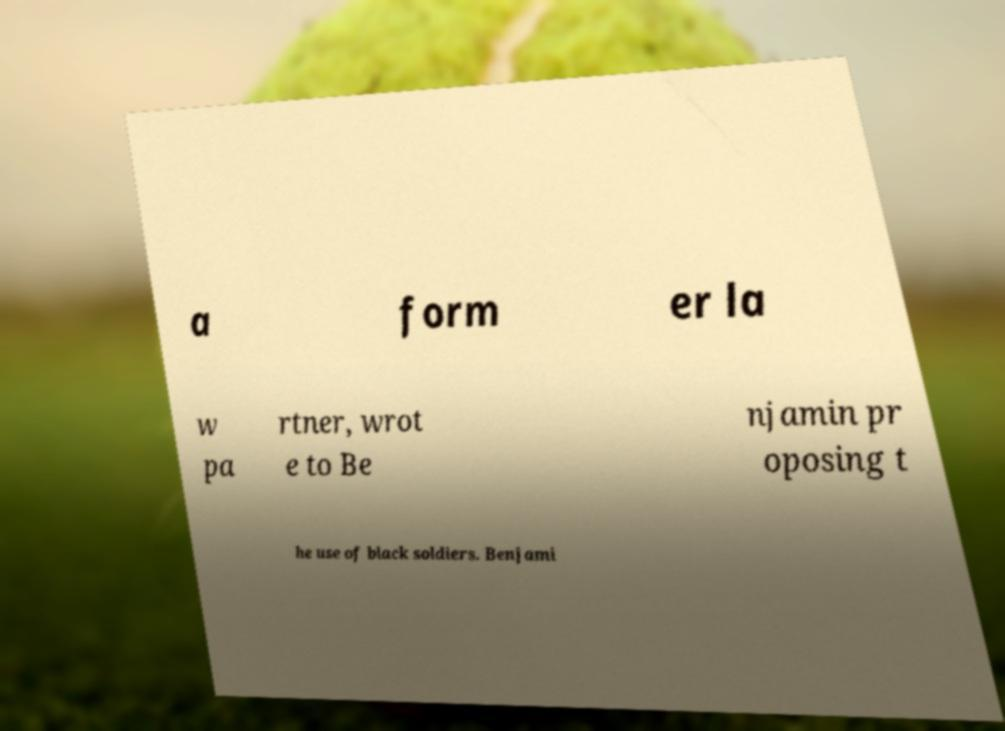There's text embedded in this image that I need extracted. Can you transcribe it verbatim? a form er la w pa rtner, wrot e to Be njamin pr oposing t he use of black soldiers. Benjami 